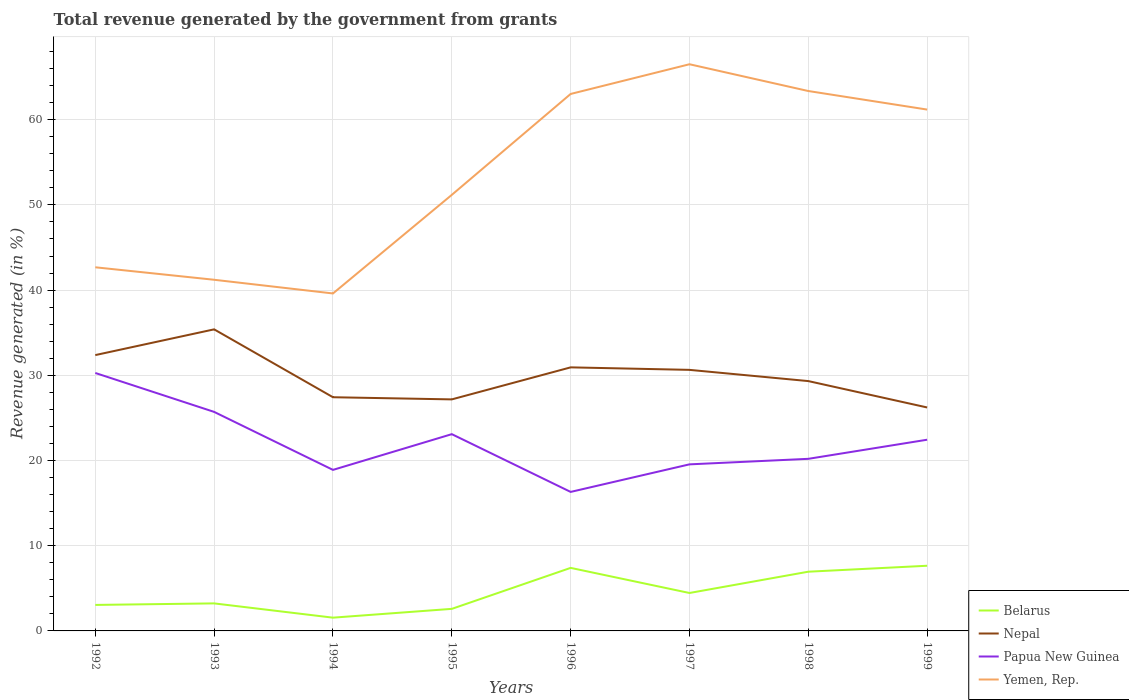Is the number of lines equal to the number of legend labels?
Your answer should be very brief. Yes. Across all years, what is the maximum total revenue generated in Belarus?
Offer a very short reply. 1.56. What is the total total revenue generated in Belarus in the graph?
Provide a short and direct response. -1.22. What is the difference between the highest and the second highest total revenue generated in Nepal?
Provide a succinct answer. 9.17. How many years are there in the graph?
Give a very brief answer. 8. Are the values on the major ticks of Y-axis written in scientific E-notation?
Your response must be concise. No. Does the graph contain grids?
Your answer should be very brief. Yes. How are the legend labels stacked?
Provide a succinct answer. Vertical. What is the title of the graph?
Provide a succinct answer. Total revenue generated by the government from grants. What is the label or title of the Y-axis?
Provide a succinct answer. Revenue generated (in %). What is the Revenue generated (in %) in Belarus in 1992?
Give a very brief answer. 3.05. What is the Revenue generated (in %) in Nepal in 1992?
Provide a short and direct response. 32.37. What is the Revenue generated (in %) in Papua New Guinea in 1992?
Offer a terse response. 30.27. What is the Revenue generated (in %) of Yemen, Rep. in 1992?
Provide a short and direct response. 42.68. What is the Revenue generated (in %) of Belarus in 1993?
Keep it short and to the point. 3.23. What is the Revenue generated (in %) of Nepal in 1993?
Give a very brief answer. 35.39. What is the Revenue generated (in %) in Papua New Guinea in 1993?
Your answer should be compact. 25.71. What is the Revenue generated (in %) of Yemen, Rep. in 1993?
Make the answer very short. 41.21. What is the Revenue generated (in %) of Belarus in 1994?
Provide a succinct answer. 1.56. What is the Revenue generated (in %) in Nepal in 1994?
Your answer should be compact. 27.43. What is the Revenue generated (in %) in Papua New Guinea in 1994?
Ensure brevity in your answer.  18.9. What is the Revenue generated (in %) of Yemen, Rep. in 1994?
Give a very brief answer. 39.61. What is the Revenue generated (in %) of Belarus in 1995?
Provide a succinct answer. 2.59. What is the Revenue generated (in %) in Nepal in 1995?
Provide a succinct answer. 27.18. What is the Revenue generated (in %) of Papua New Guinea in 1995?
Offer a terse response. 23.09. What is the Revenue generated (in %) in Yemen, Rep. in 1995?
Offer a terse response. 51.18. What is the Revenue generated (in %) in Belarus in 1996?
Ensure brevity in your answer.  7.4. What is the Revenue generated (in %) in Nepal in 1996?
Your response must be concise. 30.93. What is the Revenue generated (in %) of Papua New Guinea in 1996?
Your response must be concise. 16.32. What is the Revenue generated (in %) of Yemen, Rep. in 1996?
Your answer should be very brief. 63.02. What is the Revenue generated (in %) of Belarus in 1997?
Offer a terse response. 4.45. What is the Revenue generated (in %) of Nepal in 1997?
Offer a very short reply. 30.64. What is the Revenue generated (in %) in Papua New Guinea in 1997?
Offer a terse response. 19.55. What is the Revenue generated (in %) of Yemen, Rep. in 1997?
Offer a very short reply. 66.51. What is the Revenue generated (in %) in Belarus in 1998?
Give a very brief answer. 6.95. What is the Revenue generated (in %) in Nepal in 1998?
Provide a short and direct response. 29.32. What is the Revenue generated (in %) in Papua New Guinea in 1998?
Keep it short and to the point. 20.2. What is the Revenue generated (in %) of Yemen, Rep. in 1998?
Offer a very short reply. 63.37. What is the Revenue generated (in %) in Belarus in 1999?
Provide a short and direct response. 7.65. What is the Revenue generated (in %) in Nepal in 1999?
Give a very brief answer. 26.23. What is the Revenue generated (in %) of Papua New Guinea in 1999?
Keep it short and to the point. 22.44. What is the Revenue generated (in %) of Yemen, Rep. in 1999?
Make the answer very short. 61.19. Across all years, what is the maximum Revenue generated (in %) of Belarus?
Offer a very short reply. 7.65. Across all years, what is the maximum Revenue generated (in %) of Nepal?
Your answer should be very brief. 35.39. Across all years, what is the maximum Revenue generated (in %) of Papua New Guinea?
Your answer should be compact. 30.27. Across all years, what is the maximum Revenue generated (in %) in Yemen, Rep.?
Your answer should be compact. 66.51. Across all years, what is the minimum Revenue generated (in %) of Belarus?
Your answer should be very brief. 1.56. Across all years, what is the minimum Revenue generated (in %) in Nepal?
Ensure brevity in your answer.  26.23. Across all years, what is the minimum Revenue generated (in %) of Papua New Guinea?
Ensure brevity in your answer.  16.32. Across all years, what is the minimum Revenue generated (in %) in Yemen, Rep.?
Offer a terse response. 39.61. What is the total Revenue generated (in %) in Belarus in the graph?
Ensure brevity in your answer.  36.88. What is the total Revenue generated (in %) in Nepal in the graph?
Offer a terse response. 239.5. What is the total Revenue generated (in %) in Papua New Guinea in the graph?
Keep it short and to the point. 176.48. What is the total Revenue generated (in %) in Yemen, Rep. in the graph?
Offer a very short reply. 428.77. What is the difference between the Revenue generated (in %) of Belarus in 1992 and that in 1993?
Offer a very short reply. -0.18. What is the difference between the Revenue generated (in %) in Nepal in 1992 and that in 1993?
Give a very brief answer. -3.02. What is the difference between the Revenue generated (in %) of Papua New Guinea in 1992 and that in 1993?
Your answer should be very brief. 4.57. What is the difference between the Revenue generated (in %) in Yemen, Rep. in 1992 and that in 1993?
Your answer should be compact. 1.47. What is the difference between the Revenue generated (in %) of Belarus in 1992 and that in 1994?
Keep it short and to the point. 1.49. What is the difference between the Revenue generated (in %) of Nepal in 1992 and that in 1994?
Your answer should be compact. 4.95. What is the difference between the Revenue generated (in %) of Papua New Guinea in 1992 and that in 1994?
Provide a succinct answer. 11.37. What is the difference between the Revenue generated (in %) in Yemen, Rep. in 1992 and that in 1994?
Ensure brevity in your answer.  3.07. What is the difference between the Revenue generated (in %) of Belarus in 1992 and that in 1995?
Keep it short and to the point. 0.46. What is the difference between the Revenue generated (in %) of Nepal in 1992 and that in 1995?
Provide a short and direct response. 5.2. What is the difference between the Revenue generated (in %) of Papua New Guinea in 1992 and that in 1995?
Your response must be concise. 7.18. What is the difference between the Revenue generated (in %) in Yemen, Rep. in 1992 and that in 1995?
Ensure brevity in your answer.  -8.5. What is the difference between the Revenue generated (in %) in Belarus in 1992 and that in 1996?
Make the answer very short. -4.35. What is the difference between the Revenue generated (in %) in Nepal in 1992 and that in 1996?
Provide a succinct answer. 1.44. What is the difference between the Revenue generated (in %) in Papua New Guinea in 1992 and that in 1996?
Provide a succinct answer. 13.96. What is the difference between the Revenue generated (in %) of Yemen, Rep. in 1992 and that in 1996?
Your answer should be very brief. -20.34. What is the difference between the Revenue generated (in %) in Belarus in 1992 and that in 1997?
Offer a terse response. -1.4. What is the difference between the Revenue generated (in %) in Nepal in 1992 and that in 1997?
Make the answer very short. 1.74. What is the difference between the Revenue generated (in %) in Papua New Guinea in 1992 and that in 1997?
Your response must be concise. 10.73. What is the difference between the Revenue generated (in %) in Yemen, Rep. in 1992 and that in 1997?
Your response must be concise. -23.83. What is the difference between the Revenue generated (in %) of Belarus in 1992 and that in 1998?
Your answer should be compact. -3.9. What is the difference between the Revenue generated (in %) of Nepal in 1992 and that in 1998?
Your answer should be very brief. 3.05. What is the difference between the Revenue generated (in %) of Papua New Guinea in 1992 and that in 1998?
Provide a short and direct response. 10.08. What is the difference between the Revenue generated (in %) in Yemen, Rep. in 1992 and that in 1998?
Make the answer very short. -20.69. What is the difference between the Revenue generated (in %) in Belarus in 1992 and that in 1999?
Keep it short and to the point. -4.6. What is the difference between the Revenue generated (in %) in Nepal in 1992 and that in 1999?
Make the answer very short. 6.15. What is the difference between the Revenue generated (in %) of Papua New Guinea in 1992 and that in 1999?
Ensure brevity in your answer.  7.83. What is the difference between the Revenue generated (in %) in Yemen, Rep. in 1992 and that in 1999?
Your response must be concise. -18.51. What is the difference between the Revenue generated (in %) of Belarus in 1993 and that in 1994?
Ensure brevity in your answer.  1.67. What is the difference between the Revenue generated (in %) of Nepal in 1993 and that in 1994?
Provide a succinct answer. 7.97. What is the difference between the Revenue generated (in %) in Papua New Guinea in 1993 and that in 1994?
Your response must be concise. 6.81. What is the difference between the Revenue generated (in %) in Yemen, Rep. in 1993 and that in 1994?
Ensure brevity in your answer.  1.61. What is the difference between the Revenue generated (in %) of Belarus in 1993 and that in 1995?
Give a very brief answer. 0.64. What is the difference between the Revenue generated (in %) of Nepal in 1993 and that in 1995?
Your response must be concise. 8.22. What is the difference between the Revenue generated (in %) of Papua New Guinea in 1993 and that in 1995?
Provide a succinct answer. 2.61. What is the difference between the Revenue generated (in %) of Yemen, Rep. in 1993 and that in 1995?
Your response must be concise. -9.97. What is the difference between the Revenue generated (in %) of Belarus in 1993 and that in 1996?
Your response must be concise. -4.17. What is the difference between the Revenue generated (in %) in Nepal in 1993 and that in 1996?
Keep it short and to the point. 4.46. What is the difference between the Revenue generated (in %) in Papua New Guinea in 1993 and that in 1996?
Offer a very short reply. 9.39. What is the difference between the Revenue generated (in %) in Yemen, Rep. in 1993 and that in 1996?
Your answer should be compact. -21.81. What is the difference between the Revenue generated (in %) of Belarus in 1993 and that in 1997?
Give a very brief answer. -1.22. What is the difference between the Revenue generated (in %) of Nepal in 1993 and that in 1997?
Ensure brevity in your answer.  4.75. What is the difference between the Revenue generated (in %) in Papua New Guinea in 1993 and that in 1997?
Your response must be concise. 6.16. What is the difference between the Revenue generated (in %) of Yemen, Rep. in 1993 and that in 1997?
Your answer should be very brief. -25.3. What is the difference between the Revenue generated (in %) in Belarus in 1993 and that in 1998?
Your response must be concise. -3.72. What is the difference between the Revenue generated (in %) of Nepal in 1993 and that in 1998?
Offer a terse response. 6.07. What is the difference between the Revenue generated (in %) in Papua New Guinea in 1993 and that in 1998?
Keep it short and to the point. 5.51. What is the difference between the Revenue generated (in %) in Yemen, Rep. in 1993 and that in 1998?
Give a very brief answer. -22.15. What is the difference between the Revenue generated (in %) in Belarus in 1993 and that in 1999?
Provide a succinct answer. -4.42. What is the difference between the Revenue generated (in %) in Nepal in 1993 and that in 1999?
Your answer should be compact. 9.17. What is the difference between the Revenue generated (in %) in Papua New Guinea in 1993 and that in 1999?
Ensure brevity in your answer.  3.27. What is the difference between the Revenue generated (in %) of Yemen, Rep. in 1993 and that in 1999?
Offer a very short reply. -19.98. What is the difference between the Revenue generated (in %) in Belarus in 1994 and that in 1995?
Your answer should be very brief. -1.03. What is the difference between the Revenue generated (in %) in Nepal in 1994 and that in 1995?
Your answer should be very brief. 0.25. What is the difference between the Revenue generated (in %) in Papua New Guinea in 1994 and that in 1995?
Your response must be concise. -4.19. What is the difference between the Revenue generated (in %) of Yemen, Rep. in 1994 and that in 1995?
Ensure brevity in your answer.  -11.57. What is the difference between the Revenue generated (in %) of Belarus in 1994 and that in 1996?
Your answer should be very brief. -5.84. What is the difference between the Revenue generated (in %) of Nepal in 1994 and that in 1996?
Your answer should be very brief. -3.51. What is the difference between the Revenue generated (in %) of Papua New Guinea in 1994 and that in 1996?
Your answer should be compact. 2.59. What is the difference between the Revenue generated (in %) of Yemen, Rep. in 1994 and that in 1996?
Your response must be concise. -23.42. What is the difference between the Revenue generated (in %) of Belarus in 1994 and that in 1997?
Keep it short and to the point. -2.9. What is the difference between the Revenue generated (in %) in Nepal in 1994 and that in 1997?
Offer a very short reply. -3.21. What is the difference between the Revenue generated (in %) of Papua New Guinea in 1994 and that in 1997?
Offer a very short reply. -0.65. What is the difference between the Revenue generated (in %) in Yemen, Rep. in 1994 and that in 1997?
Provide a succinct answer. -26.9. What is the difference between the Revenue generated (in %) in Belarus in 1994 and that in 1998?
Your answer should be compact. -5.39. What is the difference between the Revenue generated (in %) of Nepal in 1994 and that in 1998?
Ensure brevity in your answer.  -1.89. What is the difference between the Revenue generated (in %) of Papua New Guinea in 1994 and that in 1998?
Make the answer very short. -1.3. What is the difference between the Revenue generated (in %) of Yemen, Rep. in 1994 and that in 1998?
Offer a terse response. -23.76. What is the difference between the Revenue generated (in %) in Belarus in 1994 and that in 1999?
Your answer should be very brief. -6.09. What is the difference between the Revenue generated (in %) of Nepal in 1994 and that in 1999?
Provide a succinct answer. 1.2. What is the difference between the Revenue generated (in %) of Papua New Guinea in 1994 and that in 1999?
Offer a very short reply. -3.54. What is the difference between the Revenue generated (in %) in Yemen, Rep. in 1994 and that in 1999?
Your answer should be very brief. -21.58. What is the difference between the Revenue generated (in %) of Belarus in 1995 and that in 1996?
Provide a short and direct response. -4.81. What is the difference between the Revenue generated (in %) of Nepal in 1995 and that in 1996?
Make the answer very short. -3.76. What is the difference between the Revenue generated (in %) of Papua New Guinea in 1995 and that in 1996?
Provide a succinct answer. 6.78. What is the difference between the Revenue generated (in %) of Yemen, Rep. in 1995 and that in 1996?
Your response must be concise. -11.84. What is the difference between the Revenue generated (in %) in Belarus in 1995 and that in 1997?
Your answer should be compact. -1.86. What is the difference between the Revenue generated (in %) in Nepal in 1995 and that in 1997?
Keep it short and to the point. -3.46. What is the difference between the Revenue generated (in %) of Papua New Guinea in 1995 and that in 1997?
Offer a terse response. 3.54. What is the difference between the Revenue generated (in %) in Yemen, Rep. in 1995 and that in 1997?
Keep it short and to the point. -15.33. What is the difference between the Revenue generated (in %) in Belarus in 1995 and that in 1998?
Provide a succinct answer. -4.36. What is the difference between the Revenue generated (in %) in Nepal in 1995 and that in 1998?
Provide a short and direct response. -2.15. What is the difference between the Revenue generated (in %) of Papua New Guinea in 1995 and that in 1998?
Provide a short and direct response. 2.9. What is the difference between the Revenue generated (in %) in Yemen, Rep. in 1995 and that in 1998?
Make the answer very short. -12.19. What is the difference between the Revenue generated (in %) of Belarus in 1995 and that in 1999?
Provide a succinct answer. -5.06. What is the difference between the Revenue generated (in %) of Nepal in 1995 and that in 1999?
Give a very brief answer. 0.95. What is the difference between the Revenue generated (in %) of Papua New Guinea in 1995 and that in 1999?
Make the answer very short. 0.65. What is the difference between the Revenue generated (in %) of Yemen, Rep. in 1995 and that in 1999?
Make the answer very short. -10.01. What is the difference between the Revenue generated (in %) in Belarus in 1996 and that in 1997?
Make the answer very short. 2.95. What is the difference between the Revenue generated (in %) in Nepal in 1996 and that in 1997?
Offer a terse response. 0.29. What is the difference between the Revenue generated (in %) of Papua New Guinea in 1996 and that in 1997?
Your response must be concise. -3.23. What is the difference between the Revenue generated (in %) in Yemen, Rep. in 1996 and that in 1997?
Keep it short and to the point. -3.49. What is the difference between the Revenue generated (in %) of Belarus in 1996 and that in 1998?
Offer a very short reply. 0.45. What is the difference between the Revenue generated (in %) of Nepal in 1996 and that in 1998?
Offer a very short reply. 1.61. What is the difference between the Revenue generated (in %) in Papua New Guinea in 1996 and that in 1998?
Provide a succinct answer. -3.88. What is the difference between the Revenue generated (in %) in Yemen, Rep. in 1996 and that in 1998?
Ensure brevity in your answer.  -0.35. What is the difference between the Revenue generated (in %) in Belarus in 1996 and that in 1999?
Offer a terse response. -0.25. What is the difference between the Revenue generated (in %) in Nepal in 1996 and that in 1999?
Provide a short and direct response. 4.71. What is the difference between the Revenue generated (in %) of Papua New Guinea in 1996 and that in 1999?
Make the answer very short. -6.13. What is the difference between the Revenue generated (in %) in Yemen, Rep. in 1996 and that in 1999?
Keep it short and to the point. 1.83. What is the difference between the Revenue generated (in %) in Belarus in 1997 and that in 1998?
Your answer should be very brief. -2.5. What is the difference between the Revenue generated (in %) in Nepal in 1997 and that in 1998?
Your answer should be very brief. 1.32. What is the difference between the Revenue generated (in %) of Papua New Guinea in 1997 and that in 1998?
Your response must be concise. -0.65. What is the difference between the Revenue generated (in %) in Yemen, Rep. in 1997 and that in 1998?
Your answer should be compact. 3.14. What is the difference between the Revenue generated (in %) of Belarus in 1997 and that in 1999?
Your answer should be compact. -3.2. What is the difference between the Revenue generated (in %) in Nepal in 1997 and that in 1999?
Keep it short and to the point. 4.41. What is the difference between the Revenue generated (in %) in Papua New Guinea in 1997 and that in 1999?
Make the answer very short. -2.89. What is the difference between the Revenue generated (in %) of Yemen, Rep. in 1997 and that in 1999?
Make the answer very short. 5.32. What is the difference between the Revenue generated (in %) of Belarus in 1998 and that in 1999?
Keep it short and to the point. -0.7. What is the difference between the Revenue generated (in %) in Nepal in 1998 and that in 1999?
Give a very brief answer. 3.09. What is the difference between the Revenue generated (in %) in Papua New Guinea in 1998 and that in 1999?
Your answer should be very brief. -2.24. What is the difference between the Revenue generated (in %) in Yemen, Rep. in 1998 and that in 1999?
Your answer should be very brief. 2.18. What is the difference between the Revenue generated (in %) in Belarus in 1992 and the Revenue generated (in %) in Nepal in 1993?
Give a very brief answer. -32.34. What is the difference between the Revenue generated (in %) of Belarus in 1992 and the Revenue generated (in %) of Papua New Guinea in 1993?
Make the answer very short. -22.66. What is the difference between the Revenue generated (in %) in Belarus in 1992 and the Revenue generated (in %) in Yemen, Rep. in 1993?
Offer a terse response. -38.16. What is the difference between the Revenue generated (in %) in Nepal in 1992 and the Revenue generated (in %) in Papua New Guinea in 1993?
Offer a terse response. 6.67. What is the difference between the Revenue generated (in %) in Nepal in 1992 and the Revenue generated (in %) in Yemen, Rep. in 1993?
Your answer should be compact. -8.84. What is the difference between the Revenue generated (in %) of Papua New Guinea in 1992 and the Revenue generated (in %) of Yemen, Rep. in 1993?
Give a very brief answer. -10.94. What is the difference between the Revenue generated (in %) of Belarus in 1992 and the Revenue generated (in %) of Nepal in 1994?
Ensure brevity in your answer.  -24.38. What is the difference between the Revenue generated (in %) in Belarus in 1992 and the Revenue generated (in %) in Papua New Guinea in 1994?
Your response must be concise. -15.85. What is the difference between the Revenue generated (in %) in Belarus in 1992 and the Revenue generated (in %) in Yemen, Rep. in 1994?
Offer a very short reply. -36.56. What is the difference between the Revenue generated (in %) in Nepal in 1992 and the Revenue generated (in %) in Papua New Guinea in 1994?
Your response must be concise. 13.47. What is the difference between the Revenue generated (in %) in Nepal in 1992 and the Revenue generated (in %) in Yemen, Rep. in 1994?
Offer a terse response. -7.23. What is the difference between the Revenue generated (in %) in Papua New Guinea in 1992 and the Revenue generated (in %) in Yemen, Rep. in 1994?
Offer a terse response. -9.33. What is the difference between the Revenue generated (in %) of Belarus in 1992 and the Revenue generated (in %) of Nepal in 1995?
Keep it short and to the point. -24.12. What is the difference between the Revenue generated (in %) in Belarus in 1992 and the Revenue generated (in %) in Papua New Guinea in 1995?
Provide a succinct answer. -20.04. What is the difference between the Revenue generated (in %) in Belarus in 1992 and the Revenue generated (in %) in Yemen, Rep. in 1995?
Keep it short and to the point. -48.13. What is the difference between the Revenue generated (in %) in Nepal in 1992 and the Revenue generated (in %) in Papua New Guinea in 1995?
Provide a short and direct response. 9.28. What is the difference between the Revenue generated (in %) of Nepal in 1992 and the Revenue generated (in %) of Yemen, Rep. in 1995?
Provide a short and direct response. -18.81. What is the difference between the Revenue generated (in %) of Papua New Guinea in 1992 and the Revenue generated (in %) of Yemen, Rep. in 1995?
Your response must be concise. -20.91. What is the difference between the Revenue generated (in %) in Belarus in 1992 and the Revenue generated (in %) in Nepal in 1996?
Keep it short and to the point. -27.88. What is the difference between the Revenue generated (in %) of Belarus in 1992 and the Revenue generated (in %) of Papua New Guinea in 1996?
Offer a very short reply. -13.26. What is the difference between the Revenue generated (in %) of Belarus in 1992 and the Revenue generated (in %) of Yemen, Rep. in 1996?
Keep it short and to the point. -59.97. What is the difference between the Revenue generated (in %) in Nepal in 1992 and the Revenue generated (in %) in Papua New Guinea in 1996?
Your response must be concise. 16.06. What is the difference between the Revenue generated (in %) of Nepal in 1992 and the Revenue generated (in %) of Yemen, Rep. in 1996?
Your answer should be very brief. -30.65. What is the difference between the Revenue generated (in %) of Papua New Guinea in 1992 and the Revenue generated (in %) of Yemen, Rep. in 1996?
Keep it short and to the point. -32.75. What is the difference between the Revenue generated (in %) of Belarus in 1992 and the Revenue generated (in %) of Nepal in 1997?
Ensure brevity in your answer.  -27.59. What is the difference between the Revenue generated (in %) of Belarus in 1992 and the Revenue generated (in %) of Papua New Guinea in 1997?
Your response must be concise. -16.5. What is the difference between the Revenue generated (in %) in Belarus in 1992 and the Revenue generated (in %) in Yemen, Rep. in 1997?
Your answer should be compact. -63.46. What is the difference between the Revenue generated (in %) of Nepal in 1992 and the Revenue generated (in %) of Papua New Guinea in 1997?
Offer a very short reply. 12.83. What is the difference between the Revenue generated (in %) of Nepal in 1992 and the Revenue generated (in %) of Yemen, Rep. in 1997?
Keep it short and to the point. -34.13. What is the difference between the Revenue generated (in %) of Papua New Guinea in 1992 and the Revenue generated (in %) of Yemen, Rep. in 1997?
Offer a very short reply. -36.23. What is the difference between the Revenue generated (in %) of Belarus in 1992 and the Revenue generated (in %) of Nepal in 1998?
Give a very brief answer. -26.27. What is the difference between the Revenue generated (in %) of Belarus in 1992 and the Revenue generated (in %) of Papua New Guinea in 1998?
Your response must be concise. -17.15. What is the difference between the Revenue generated (in %) in Belarus in 1992 and the Revenue generated (in %) in Yemen, Rep. in 1998?
Provide a succinct answer. -60.32. What is the difference between the Revenue generated (in %) in Nepal in 1992 and the Revenue generated (in %) in Papua New Guinea in 1998?
Your answer should be compact. 12.18. What is the difference between the Revenue generated (in %) of Nepal in 1992 and the Revenue generated (in %) of Yemen, Rep. in 1998?
Your answer should be very brief. -30.99. What is the difference between the Revenue generated (in %) in Papua New Guinea in 1992 and the Revenue generated (in %) in Yemen, Rep. in 1998?
Make the answer very short. -33.09. What is the difference between the Revenue generated (in %) in Belarus in 1992 and the Revenue generated (in %) in Nepal in 1999?
Keep it short and to the point. -23.18. What is the difference between the Revenue generated (in %) in Belarus in 1992 and the Revenue generated (in %) in Papua New Guinea in 1999?
Your answer should be compact. -19.39. What is the difference between the Revenue generated (in %) of Belarus in 1992 and the Revenue generated (in %) of Yemen, Rep. in 1999?
Your answer should be compact. -58.14. What is the difference between the Revenue generated (in %) of Nepal in 1992 and the Revenue generated (in %) of Papua New Guinea in 1999?
Your response must be concise. 9.93. What is the difference between the Revenue generated (in %) in Nepal in 1992 and the Revenue generated (in %) in Yemen, Rep. in 1999?
Offer a terse response. -28.82. What is the difference between the Revenue generated (in %) in Papua New Guinea in 1992 and the Revenue generated (in %) in Yemen, Rep. in 1999?
Keep it short and to the point. -30.92. What is the difference between the Revenue generated (in %) of Belarus in 1993 and the Revenue generated (in %) of Nepal in 1994?
Offer a very short reply. -24.2. What is the difference between the Revenue generated (in %) in Belarus in 1993 and the Revenue generated (in %) in Papua New Guinea in 1994?
Your answer should be very brief. -15.67. What is the difference between the Revenue generated (in %) in Belarus in 1993 and the Revenue generated (in %) in Yemen, Rep. in 1994?
Your response must be concise. -36.38. What is the difference between the Revenue generated (in %) in Nepal in 1993 and the Revenue generated (in %) in Papua New Guinea in 1994?
Ensure brevity in your answer.  16.49. What is the difference between the Revenue generated (in %) of Nepal in 1993 and the Revenue generated (in %) of Yemen, Rep. in 1994?
Give a very brief answer. -4.21. What is the difference between the Revenue generated (in %) in Belarus in 1993 and the Revenue generated (in %) in Nepal in 1995?
Your answer should be very brief. -23.94. What is the difference between the Revenue generated (in %) in Belarus in 1993 and the Revenue generated (in %) in Papua New Guinea in 1995?
Provide a succinct answer. -19.86. What is the difference between the Revenue generated (in %) of Belarus in 1993 and the Revenue generated (in %) of Yemen, Rep. in 1995?
Offer a terse response. -47.95. What is the difference between the Revenue generated (in %) of Nepal in 1993 and the Revenue generated (in %) of Papua New Guinea in 1995?
Provide a succinct answer. 12.3. What is the difference between the Revenue generated (in %) of Nepal in 1993 and the Revenue generated (in %) of Yemen, Rep. in 1995?
Your answer should be compact. -15.79. What is the difference between the Revenue generated (in %) in Papua New Guinea in 1993 and the Revenue generated (in %) in Yemen, Rep. in 1995?
Provide a short and direct response. -25.47. What is the difference between the Revenue generated (in %) in Belarus in 1993 and the Revenue generated (in %) in Nepal in 1996?
Make the answer very short. -27.7. What is the difference between the Revenue generated (in %) in Belarus in 1993 and the Revenue generated (in %) in Papua New Guinea in 1996?
Your response must be concise. -13.08. What is the difference between the Revenue generated (in %) in Belarus in 1993 and the Revenue generated (in %) in Yemen, Rep. in 1996?
Offer a very short reply. -59.79. What is the difference between the Revenue generated (in %) in Nepal in 1993 and the Revenue generated (in %) in Papua New Guinea in 1996?
Provide a succinct answer. 19.08. What is the difference between the Revenue generated (in %) of Nepal in 1993 and the Revenue generated (in %) of Yemen, Rep. in 1996?
Ensure brevity in your answer.  -27.63. What is the difference between the Revenue generated (in %) of Papua New Guinea in 1993 and the Revenue generated (in %) of Yemen, Rep. in 1996?
Make the answer very short. -37.32. What is the difference between the Revenue generated (in %) of Belarus in 1993 and the Revenue generated (in %) of Nepal in 1997?
Your answer should be very brief. -27.41. What is the difference between the Revenue generated (in %) in Belarus in 1993 and the Revenue generated (in %) in Papua New Guinea in 1997?
Provide a short and direct response. -16.32. What is the difference between the Revenue generated (in %) of Belarus in 1993 and the Revenue generated (in %) of Yemen, Rep. in 1997?
Provide a succinct answer. -63.28. What is the difference between the Revenue generated (in %) in Nepal in 1993 and the Revenue generated (in %) in Papua New Guinea in 1997?
Offer a very short reply. 15.84. What is the difference between the Revenue generated (in %) in Nepal in 1993 and the Revenue generated (in %) in Yemen, Rep. in 1997?
Offer a terse response. -31.12. What is the difference between the Revenue generated (in %) of Papua New Guinea in 1993 and the Revenue generated (in %) of Yemen, Rep. in 1997?
Make the answer very short. -40.8. What is the difference between the Revenue generated (in %) in Belarus in 1993 and the Revenue generated (in %) in Nepal in 1998?
Your answer should be compact. -26.09. What is the difference between the Revenue generated (in %) in Belarus in 1993 and the Revenue generated (in %) in Papua New Guinea in 1998?
Offer a terse response. -16.97. What is the difference between the Revenue generated (in %) in Belarus in 1993 and the Revenue generated (in %) in Yemen, Rep. in 1998?
Keep it short and to the point. -60.14. What is the difference between the Revenue generated (in %) of Nepal in 1993 and the Revenue generated (in %) of Papua New Guinea in 1998?
Provide a short and direct response. 15.2. What is the difference between the Revenue generated (in %) in Nepal in 1993 and the Revenue generated (in %) in Yemen, Rep. in 1998?
Your answer should be compact. -27.97. What is the difference between the Revenue generated (in %) of Papua New Guinea in 1993 and the Revenue generated (in %) of Yemen, Rep. in 1998?
Your answer should be very brief. -37.66. What is the difference between the Revenue generated (in %) in Belarus in 1993 and the Revenue generated (in %) in Nepal in 1999?
Offer a very short reply. -23. What is the difference between the Revenue generated (in %) in Belarus in 1993 and the Revenue generated (in %) in Papua New Guinea in 1999?
Offer a very short reply. -19.21. What is the difference between the Revenue generated (in %) in Belarus in 1993 and the Revenue generated (in %) in Yemen, Rep. in 1999?
Give a very brief answer. -57.96. What is the difference between the Revenue generated (in %) in Nepal in 1993 and the Revenue generated (in %) in Papua New Guinea in 1999?
Make the answer very short. 12.95. What is the difference between the Revenue generated (in %) in Nepal in 1993 and the Revenue generated (in %) in Yemen, Rep. in 1999?
Ensure brevity in your answer.  -25.8. What is the difference between the Revenue generated (in %) of Papua New Guinea in 1993 and the Revenue generated (in %) of Yemen, Rep. in 1999?
Give a very brief answer. -35.48. What is the difference between the Revenue generated (in %) in Belarus in 1994 and the Revenue generated (in %) in Nepal in 1995?
Offer a very short reply. -25.62. What is the difference between the Revenue generated (in %) in Belarus in 1994 and the Revenue generated (in %) in Papua New Guinea in 1995?
Keep it short and to the point. -21.54. What is the difference between the Revenue generated (in %) in Belarus in 1994 and the Revenue generated (in %) in Yemen, Rep. in 1995?
Your answer should be very brief. -49.62. What is the difference between the Revenue generated (in %) in Nepal in 1994 and the Revenue generated (in %) in Papua New Guinea in 1995?
Provide a short and direct response. 4.33. What is the difference between the Revenue generated (in %) of Nepal in 1994 and the Revenue generated (in %) of Yemen, Rep. in 1995?
Provide a succinct answer. -23.75. What is the difference between the Revenue generated (in %) of Papua New Guinea in 1994 and the Revenue generated (in %) of Yemen, Rep. in 1995?
Your response must be concise. -32.28. What is the difference between the Revenue generated (in %) in Belarus in 1994 and the Revenue generated (in %) in Nepal in 1996?
Your response must be concise. -29.38. What is the difference between the Revenue generated (in %) in Belarus in 1994 and the Revenue generated (in %) in Papua New Guinea in 1996?
Your answer should be very brief. -14.76. What is the difference between the Revenue generated (in %) of Belarus in 1994 and the Revenue generated (in %) of Yemen, Rep. in 1996?
Your response must be concise. -61.47. What is the difference between the Revenue generated (in %) of Nepal in 1994 and the Revenue generated (in %) of Papua New Guinea in 1996?
Keep it short and to the point. 11.11. What is the difference between the Revenue generated (in %) of Nepal in 1994 and the Revenue generated (in %) of Yemen, Rep. in 1996?
Offer a terse response. -35.59. What is the difference between the Revenue generated (in %) of Papua New Guinea in 1994 and the Revenue generated (in %) of Yemen, Rep. in 1996?
Provide a succinct answer. -44.12. What is the difference between the Revenue generated (in %) in Belarus in 1994 and the Revenue generated (in %) in Nepal in 1997?
Your answer should be very brief. -29.08. What is the difference between the Revenue generated (in %) of Belarus in 1994 and the Revenue generated (in %) of Papua New Guinea in 1997?
Provide a succinct answer. -17.99. What is the difference between the Revenue generated (in %) of Belarus in 1994 and the Revenue generated (in %) of Yemen, Rep. in 1997?
Offer a very short reply. -64.95. What is the difference between the Revenue generated (in %) of Nepal in 1994 and the Revenue generated (in %) of Papua New Guinea in 1997?
Your response must be concise. 7.88. What is the difference between the Revenue generated (in %) in Nepal in 1994 and the Revenue generated (in %) in Yemen, Rep. in 1997?
Ensure brevity in your answer.  -39.08. What is the difference between the Revenue generated (in %) in Papua New Guinea in 1994 and the Revenue generated (in %) in Yemen, Rep. in 1997?
Offer a very short reply. -47.61. What is the difference between the Revenue generated (in %) of Belarus in 1994 and the Revenue generated (in %) of Nepal in 1998?
Your response must be concise. -27.77. What is the difference between the Revenue generated (in %) of Belarus in 1994 and the Revenue generated (in %) of Papua New Guinea in 1998?
Keep it short and to the point. -18.64. What is the difference between the Revenue generated (in %) of Belarus in 1994 and the Revenue generated (in %) of Yemen, Rep. in 1998?
Offer a terse response. -61.81. What is the difference between the Revenue generated (in %) in Nepal in 1994 and the Revenue generated (in %) in Papua New Guinea in 1998?
Your response must be concise. 7.23. What is the difference between the Revenue generated (in %) in Nepal in 1994 and the Revenue generated (in %) in Yemen, Rep. in 1998?
Provide a succinct answer. -35.94. What is the difference between the Revenue generated (in %) of Papua New Guinea in 1994 and the Revenue generated (in %) of Yemen, Rep. in 1998?
Keep it short and to the point. -44.47. What is the difference between the Revenue generated (in %) of Belarus in 1994 and the Revenue generated (in %) of Nepal in 1999?
Ensure brevity in your answer.  -24.67. What is the difference between the Revenue generated (in %) of Belarus in 1994 and the Revenue generated (in %) of Papua New Guinea in 1999?
Give a very brief answer. -20.88. What is the difference between the Revenue generated (in %) in Belarus in 1994 and the Revenue generated (in %) in Yemen, Rep. in 1999?
Your response must be concise. -59.63. What is the difference between the Revenue generated (in %) in Nepal in 1994 and the Revenue generated (in %) in Papua New Guinea in 1999?
Provide a succinct answer. 4.99. What is the difference between the Revenue generated (in %) of Nepal in 1994 and the Revenue generated (in %) of Yemen, Rep. in 1999?
Your response must be concise. -33.76. What is the difference between the Revenue generated (in %) of Papua New Guinea in 1994 and the Revenue generated (in %) of Yemen, Rep. in 1999?
Offer a very short reply. -42.29. What is the difference between the Revenue generated (in %) of Belarus in 1995 and the Revenue generated (in %) of Nepal in 1996?
Offer a very short reply. -28.34. What is the difference between the Revenue generated (in %) of Belarus in 1995 and the Revenue generated (in %) of Papua New Guinea in 1996?
Give a very brief answer. -13.73. What is the difference between the Revenue generated (in %) in Belarus in 1995 and the Revenue generated (in %) in Yemen, Rep. in 1996?
Offer a terse response. -60.43. What is the difference between the Revenue generated (in %) in Nepal in 1995 and the Revenue generated (in %) in Papua New Guinea in 1996?
Provide a succinct answer. 10.86. What is the difference between the Revenue generated (in %) of Nepal in 1995 and the Revenue generated (in %) of Yemen, Rep. in 1996?
Ensure brevity in your answer.  -35.85. What is the difference between the Revenue generated (in %) in Papua New Guinea in 1995 and the Revenue generated (in %) in Yemen, Rep. in 1996?
Make the answer very short. -39.93. What is the difference between the Revenue generated (in %) of Belarus in 1995 and the Revenue generated (in %) of Nepal in 1997?
Make the answer very short. -28.05. What is the difference between the Revenue generated (in %) of Belarus in 1995 and the Revenue generated (in %) of Papua New Guinea in 1997?
Make the answer very short. -16.96. What is the difference between the Revenue generated (in %) in Belarus in 1995 and the Revenue generated (in %) in Yemen, Rep. in 1997?
Your response must be concise. -63.92. What is the difference between the Revenue generated (in %) of Nepal in 1995 and the Revenue generated (in %) of Papua New Guinea in 1997?
Offer a terse response. 7.63. What is the difference between the Revenue generated (in %) of Nepal in 1995 and the Revenue generated (in %) of Yemen, Rep. in 1997?
Give a very brief answer. -39.33. What is the difference between the Revenue generated (in %) in Papua New Guinea in 1995 and the Revenue generated (in %) in Yemen, Rep. in 1997?
Provide a succinct answer. -43.42. What is the difference between the Revenue generated (in %) of Belarus in 1995 and the Revenue generated (in %) of Nepal in 1998?
Provide a short and direct response. -26.73. What is the difference between the Revenue generated (in %) of Belarus in 1995 and the Revenue generated (in %) of Papua New Guinea in 1998?
Ensure brevity in your answer.  -17.61. What is the difference between the Revenue generated (in %) in Belarus in 1995 and the Revenue generated (in %) in Yemen, Rep. in 1998?
Keep it short and to the point. -60.78. What is the difference between the Revenue generated (in %) in Nepal in 1995 and the Revenue generated (in %) in Papua New Guinea in 1998?
Keep it short and to the point. 6.98. What is the difference between the Revenue generated (in %) in Nepal in 1995 and the Revenue generated (in %) in Yemen, Rep. in 1998?
Keep it short and to the point. -36.19. What is the difference between the Revenue generated (in %) in Papua New Guinea in 1995 and the Revenue generated (in %) in Yemen, Rep. in 1998?
Your response must be concise. -40.27. What is the difference between the Revenue generated (in %) in Belarus in 1995 and the Revenue generated (in %) in Nepal in 1999?
Your answer should be very brief. -23.64. What is the difference between the Revenue generated (in %) in Belarus in 1995 and the Revenue generated (in %) in Papua New Guinea in 1999?
Offer a terse response. -19.85. What is the difference between the Revenue generated (in %) of Belarus in 1995 and the Revenue generated (in %) of Yemen, Rep. in 1999?
Your answer should be compact. -58.6. What is the difference between the Revenue generated (in %) in Nepal in 1995 and the Revenue generated (in %) in Papua New Guinea in 1999?
Ensure brevity in your answer.  4.73. What is the difference between the Revenue generated (in %) in Nepal in 1995 and the Revenue generated (in %) in Yemen, Rep. in 1999?
Provide a short and direct response. -34.01. What is the difference between the Revenue generated (in %) in Papua New Guinea in 1995 and the Revenue generated (in %) in Yemen, Rep. in 1999?
Your answer should be compact. -38.1. What is the difference between the Revenue generated (in %) of Belarus in 1996 and the Revenue generated (in %) of Nepal in 1997?
Offer a very short reply. -23.24. What is the difference between the Revenue generated (in %) in Belarus in 1996 and the Revenue generated (in %) in Papua New Guinea in 1997?
Provide a succinct answer. -12.15. What is the difference between the Revenue generated (in %) of Belarus in 1996 and the Revenue generated (in %) of Yemen, Rep. in 1997?
Your response must be concise. -59.11. What is the difference between the Revenue generated (in %) in Nepal in 1996 and the Revenue generated (in %) in Papua New Guinea in 1997?
Provide a succinct answer. 11.38. What is the difference between the Revenue generated (in %) in Nepal in 1996 and the Revenue generated (in %) in Yemen, Rep. in 1997?
Give a very brief answer. -35.58. What is the difference between the Revenue generated (in %) in Papua New Guinea in 1996 and the Revenue generated (in %) in Yemen, Rep. in 1997?
Give a very brief answer. -50.19. What is the difference between the Revenue generated (in %) in Belarus in 1996 and the Revenue generated (in %) in Nepal in 1998?
Ensure brevity in your answer.  -21.92. What is the difference between the Revenue generated (in %) of Belarus in 1996 and the Revenue generated (in %) of Papua New Guinea in 1998?
Your answer should be very brief. -12.8. What is the difference between the Revenue generated (in %) of Belarus in 1996 and the Revenue generated (in %) of Yemen, Rep. in 1998?
Offer a terse response. -55.97. What is the difference between the Revenue generated (in %) of Nepal in 1996 and the Revenue generated (in %) of Papua New Guinea in 1998?
Provide a succinct answer. 10.74. What is the difference between the Revenue generated (in %) in Nepal in 1996 and the Revenue generated (in %) in Yemen, Rep. in 1998?
Your response must be concise. -32.43. What is the difference between the Revenue generated (in %) in Papua New Guinea in 1996 and the Revenue generated (in %) in Yemen, Rep. in 1998?
Provide a succinct answer. -47.05. What is the difference between the Revenue generated (in %) of Belarus in 1996 and the Revenue generated (in %) of Nepal in 1999?
Make the answer very short. -18.83. What is the difference between the Revenue generated (in %) in Belarus in 1996 and the Revenue generated (in %) in Papua New Guinea in 1999?
Offer a terse response. -15.04. What is the difference between the Revenue generated (in %) of Belarus in 1996 and the Revenue generated (in %) of Yemen, Rep. in 1999?
Your response must be concise. -53.79. What is the difference between the Revenue generated (in %) in Nepal in 1996 and the Revenue generated (in %) in Papua New Guinea in 1999?
Offer a terse response. 8.49. What is the difference between the Revenue generated (in %) of Nepal in 1996 and the Revenue generated (in %) of Yemen, Rep. in 1999?
Offer a very short reply. -30.26. What is the difference between the Revenue generated (in %) of Papua New Guinea in 1996 and the Revenue generated (in %) of Yemen, Rep. in 1999?
Keep it short and to the point. -44.87. What is the difference between the Revenue generated (in %) of Belarus in 1997 and the Revenue generated (in %) of Nepal in 1998?
Keep it short and to the point. -24.87. What is the difference between the Revenue generated (in %) in Belarus in 1997 and the Revenue generated (in %) in Papua New Guinea in 1998?
Give a very brief answer. -15.75. What is the difference between the Revenue generated (in %) of Belarus in 1997 and the Revenue generated (in %) of Yemen, Rep. in 1998?
Make the answer very short. -58.92. What is the difference between the Revenue generated (in %) in Nepal in 1997 and the Revenue generated (in %) in Papua New Guinea in 1998?
Make the answer very short. 10.44. What is the difference between the Revenue generated (in %) of Nepal in 1997 and the Revenue generated (in %) of Yemen, Rep. in 1998?
Give a very brief answer. -32.73. What is the difference between the Revenue generated (in %) in Papua New Guinea in 1997 and the Revenue generated (in %) in Yemen, Rep. in 1998?
Your answer should be very brief. -43.82. What is the difference between the Revenue generated (in %) in Belarus in 1997 and the Revenue generated (in %) in Nepal in 1999?
Ensure brevity in your answer.  -21.78. What is the difference between the Revenue generated (in %) of Belarus in 1997 and the Revenue generated (in %) of Papua New Guinea in 1999?
Keep it short and to the point. -17.99. What is the difference between the Revenue generated (in %) in Belarus in 1997 and the Revenue generated (in %) in Yemen, Rep. in 1999?
Your answer should be very brief. -56.74. What is the difference between the Revenue generated (in %) in Nepal in 1997 and the Revenue generated (in %) in Papua New Guinea in 1999?
Make the answer very short. 8.2. What is the difference between the Revenue generated (in %) in Nepal in 1997 and the Revenue generated (in %) in Yemen, Rep. in 1999?
Offer a terse response. -30.55. What is the difference between the Revenue generated (in %) in Papua New Guinea in 1997 and the Revenue generated (in %) in Yemen, Rep. in 1999?
Your answer should be compact. -41.64. What is the difference between the Revenue generated (in %) in Belarus in 1998 and the Revenue generated (in %) in Nepal in 1999?
Your response must be concise. -19.28. What is the difference between the Revenue generated (in %) of Belarus in 1998 and the Revenue generated (in %) of Papua New Guinea in 1999?
Your answer should be compact. -15.49. What is the difference between the Revenue generated (in %) in Belarus in 1998 and the Revenue generated (in %) in Yemen, Rep. in 1999?
Keep it short and to the point. -54.24. What is the difference between the Revenue generated (in %) in Nepal in 1998 and the Revenue generated (in %) in Papua New Guinea in 1999?
Offer a very short reply. 6.88. What is the difference between the Revenue generated (in %) in Nepal in 1998 and the Revenue generated (in %) in Yemen, Rep. in 1999?
Your answer should be very brief. -31.87. What is the difference between the Revenue generated (in %) in Papua New Guinea in 1998 and the Revenue generated (in %) in Yemen, Rep. in 1999?
Offer a very short reply. -40.99. What is the average Revenue generated (in %) of Belarus per year?
Provide a short and direct response. 4.61. What is the average Revenue generated (in %) of Nepal per year?
Provide a succinct answer. 29.94. What is the average Revenue generated (in %) of Papua New Guinea per year?
Give a very brief answer. 22.06. What is the average Revenue generated (in %) of Yemen, Rep. per year?
Give a very brief answer. 53.6. In the year 1992, what is the difference between the Revenue generated (in %) of Belarus and Revenue generated (in %) of Nepal?
Keep it short and to the point. -29.32. In the year 1992, what is the difference between the Revenue generated (in %) of Belarus and Revenue generated (in %) of Papua New Guinea?
Your answer should be very brief. -27.22. In the year 1992, what is the difference between the Revenue generated (in %) in Belarus and Revenue generated (in %) in Yemen, Rep.?
Your response must be concise. -39.63. In the year 1992, what is the difference between the Revenue generated (in %) of Nepal and Revenue generated (in %) of Papua New Guinea?
Offer a terse response. 2.1. In the year 1992, what is the difference between the Revenue generated (in %) of Nepal and Revenue generated (in %) of Yemen, Rep.?
Ensure brevity in your answer.  -10.3. In the year 1992, what is the difference between the Revenue generated (in %) of Papua New Guinea and Revenue generated (in %) of Yemen, Rep.?
Provide a succinct answer. -12.4. In the year 1993, what is the difference between the Revenue generated (in %) of Belarus and Revenue generated (in %) of Nepal?
Keep it short and to the point. -32.16. In the year 1993, what is the difference between the Revenue generated (in %) in Belarus and Revenue generated (in %) in Papua New Guinea?
Your answer should be very brief. -22.48. In the year 1993, what is the difference between the Revenue generated (in %) in Belarus and Revenue generated (in %) in Yemen, Rep.?
Offer a very short reply. -37.98. In the year 1993, what is the difference between the Revenue generated (in %) of Nepal and Revenue generated (in %) of Papua New Guinea?
Keep it short and to the point. 9.69. In the year 1993, what is the difference between the Revenue generated (in %) of Nepal and Revenue generated (in %) of Yemen, Rep.?
Offer a terse response. -5.82. In the year 1993, what is the difference between the Revenue generated (in %) in Papua New Guinea and Revenue generated (in %) in Yemen, Rep.?
Your response must be concise. -15.51. In the year 1994, what is the difference between the Revenue generated (in %) of Belarus and Revenue generated (in %) of Nepal?
Ensure brevity in your answer.  -25.87. In the year 1994, what is the difference between the Revenue generated (in %) in Belarus and Revenue generated (in %) in Papua New Guinea?
Offer a terse response. -17.34. In the year 1994, what is the difference between the Revenue generated (in %) in Belarus and Revenue generated (in %) in Yemen, Rep.?
Your answer should be very brief. -38.05. In the year 1994, what is the difference between the Revenue generated (in %) in Nepal and Revenue generated (in %) in Papua New Guinea?
Keep it short and to the point. 8.53. In the year 1994, what is the difference between the Revenue generated (in %) in Nepal and Revenue generated (in %) in Yemen, Rep.?
Offer a terse response. -12.18. In the year 1994, what is the difference between the Revenue generated (in %) of Papua New Guinea and Revenue generated (in %) of Yemen, Rep.?
Provide a succinct answer. -20.71. In the year 1995, what is the difference between the Revenue generated (in %) of Belarus and Revenue generated (in %) of Nepal?
Provide a succinct answer. -24.59. In the year 1995, what is the difference between the Revenue generated (in %) of Belarus and Revenue generated (in %) of Papua New Guinea?
Offer a very short reply. -20.51. In the year 1995, what is the difference between the Revenue generated (in %) in Belarus and Revenue generated (in %) in Yemen, Rep.?
Provide a short and direct response. -48.59. In the year 1995, what is the difference between the Revenue generated (in %) in Nepal and Revenue generated (in %) in Papua New Guinea?
Offer a terse response. 4.08. In the year 1995, what is the difference between the Revenue generated (in %) of Nepal and Revenue generated (in %) of Yemen, Rep.?
Give a very brief answer. -24. In the year 1995, what is the difference between the Revenue generated (in %) of Papua New Guinea and Revenue generated (in %) of Yemen, Rep.?
Your response must be concise. -28.09. In the year 1996, what is the difference between the Revenue generated (in %) of Belarus and Revenue generated (in %) of Nepal?
Your response must be concise. -23.53. In the year 1996, what is the difference between the Revenue generated (in %) of Belarus and Revenue generated (in %) of Papua New Guinea?
Offer a very short reply. -8.92. In the year 1996, what is the difference between the Revenue generated (in %) of Belarus and Revenue generated (in %) of Yemen, Rep.?
Keep it short and to the point. -55.62. In the year 1996, what is the difference between the Revenue generated (in %) of Nepal and Revenue generated (in %) of Papua New Guinea?
Provide a succinct answer. 14.62. In the year 1996, what is the difference between the Revenue generated (in %) in Nepal and Revenue generated (in %) in Yemen, Rep.?
Keep it short and to the point. -32.09. In the year 1996, what is the difference between the Revenue generated (in %) of Papua New Guinea and Revenue generated (in %) of Yemen, Rep.?
Your response must be concise. -46.71. In the year 1997, what is the difference between the Revenue generated (in %) of Belarus and Revenue generated (in %) of Nepal?
Give a very brief answer. -26.19. In the year 1997, what is the difference between the Revenue generated (in %) of Belarus and Revenue generated (in %) of Papua New Guinea?
Offer a very short reply. -15.1. In the year 1997, what is the difference between the Revenue generated (in %) of Belarus and Revenue generated (in %) of Yemen, Rep.?
Provide a short and direct response. -62.06. In the year 1997, what is the difference between the Revenue generated (in %) of Nepal and Revenue generated (in %) of Papua New Guinea?
Make the answer very short. 11.09. In the year 1997, what is the difference between the Revenue generated (in %) of Nepal and Revenue generated (in %) of Yemen, Rep.?
Give a very brief answer. -35.87. In the year 1997, what is the difference between the Revenue generated (in %) of Papua New Guinea and Revenue generated (in %) of Yemen, Rep.?
Offer a terse response. -46.96. In the year 1998, what is the difference between the Revenue generated (in %) of Belarus and Revenue generated (in %) of Nepal?
Your response must be concise. -22.37. In the year 1998, what is the difference between the Revenue generated (in %) in Belarus and Revenue generated (in %) in Papua New Guinea?
Your answer should be very brief. -13.25. In the year 1998, what is the difference between the Revenue generated (in %) of Belarus and Revenue generated (in %) of Yemen, Rep.?
Offer a very short reply. -56.42. In the year 1998, what is the difference between the Revenue generated (in %) in Nepal and Revenue generated (in %) in Papua New Guinea?
Offer a terse response. 9.12. In the year 1998, what is the difference between the Revenue generated (in %) of Nepal and Revenue generated (in %) of Yemen, Rep.?
Provide a succinct answer. -34.05. In the year 1998, what is the difference between the Revenue generated (in %) in Papua New Guinea and Revenue generated (in %) in Yemen, Rep.?
Give a very brief answer. -43.17. In the year 1999, what is the difference between the Revenue generated (in %) in Belarus and Revenue generated (in %) in Nepal?
Make the answer very short. -18.58. In the year 1999, what is the difference between the Revenue generated (in %) of Belarus and Revenue generated (in %) of Papua New Guinea?
Your response must be concise. -14.79. In the year 1999, what is the difference between the Revenue generated (in %) of Belarus and Revenue generated (in %) of Yemen, Rep.?
Your answer should be compact. -53.54. In the year 1999, what is the difference between the Revenue generated (in %) of Nepal and Revenue generated (in %) of Papua New Guinea?
Ensure brevity in your answer.  3.79. In the year 1999, what is the difference between the Revenue generated (in %) in Nepal and Revenue generated (in %) in Yemen, Rep.?
Make the answer very short. -34.96. In the year 1999, what is the difference between the Revenue generated (in %) in Papua New Guinea and Revenue generated (in %) in Yemen, Rep.?
Give a very brief answer. -38.75. What is the ratio of the Revenue generated (in %) of Belarus in 1992 to that in 1993?
Keep it short and to the point. 0.94. What is the ratio of the Revenue generated (in %) of Nepal in 1992 to that in 1993?
Your answer should be compact. 0.91. What is the ratio of the Revenue generated (in %) of Papua New Guinea in 1992 to that in 1993?
Your answer should be compact. 1.18. What is the ratio of the Revenue generated (in %) in Yemen, Rep. in 1992 to that in 1993?
Offer a terse response. 1.04. What is the ratio of the Revenue generated (in %) of Belarus in 1992 to that in 1994?
Provide a short and direct response. 1.96. What is the ratio of the Revenue generated (in %) of Nepal in 1992 to that in 1994?
Provide a short and direct response. 1.18. What is the ratio of the Revenue generated (in %) of Papua New Guinea in 1992 to that in 1994?
Your answer should be compact. 1.6. What is the ratio of the Revenue generated (in %) in Yemen, Rep. in 1992 to that in 1994?
Offer a very short reply. 1.08. What is the ratio of the Revenue generated (in %) of Belarus in 1992 to that in 1995?
Offer a very short reply. 1.18. What is the ratio of the Revenue generated (in %) in Nepal in 1992 to that in 1995?
Give a very brief answer. 1.19. What is the ratio of the Revenue generated (in %) in Papua New Guinea in 1992 to that in 1995?
Offer a very short reply. 1.31. What is the ratio of the Revenue generated (in %) of Yemen, Rep. in 1992 to that in 1995?
Provide a short and direct response. 0.83. What is the ratio of the Revenue generated (in %) in Belarus in 1992 to that in 1996?
Keep it short and to the point. 0.41. What is the ratio of the Revenue generated (in %) of Nepal in 1992 to that in 1996?
Give a very brief answer. 1.05. What is the ratio of the Revenue generated (in %) in Papua New Guinea in 1992 to that in 1996?
Your answer should be very brief. 1.86. What is the ratio of the Revenue generated (in %) of Yemen, Rep. in 1992 to that in 1996?
Ensure brevity in your answer.  0.68. What is the ratio of the Revenue generated (in %) of Belarus in 1992 to that in 1997?
Offer a terse response. 0.69. What is the ratio of the Revenue generated (in %) in Nepal in 1992 to that in 1997?
Offer a very short reply. 1.06. What is the ratio of the Revenue generated (in %) of Papua New Guinea in 1992 to that in 1997?
Keep it short and to the point. 1.55. What is the ratio of the Revenue generated (in %) in Yemen, Rep. in 1992 to that in 1997?
Give a very brief answer. 0.64. What is the ratio of the Revenue generated (in %) of Belarus in 1992 to that in 1998?
Provide a short and direct response. 0.44. What is the ratio of the Revenue generated (in %) of Nepal in 1992 to that in 1998?
Ensure brevity in your answer.  1.1. What is the ratio of the Revenue generated (in %) of Papua New Guinea in 1992 to that in 1998?
Give a very brief answer. 1.5. What is the ratio of the Revenue generated (in %) in Yemen, Rep. in 1992 to that in 1998?
Give a very brief answer. 0.67. What is the ratio of the Revenue generated (in %) of Belarus in 1992 to that in 1999?
Provide a succinct answer. 0.4. What is the ratio of the Revenue generated (in %) of Nepal in 1992 to that in 1999?
Provide a succinct answer. 1.23. What is the ratio of the Revenue generated (in %) of Papua New Guinea in 1992 to that in 1999?
Ensure brevity in your answer.  1.35. What is the ratio of the Revenue generated (in %) in Yemen, Rep. in 1992 to that in 1999?
Your response must be concise. 0.7. What is the ratio of the Revenue generated (in %) in Belarus in 1993 to that in 1994?
Keep it short and to the point. 2.08. What is the ratio of the Revenue generated (in %) of Nepal in 1993 to that in 1994?
Your answer should be compact. 1.29. What is the ratio of the Revenue generated (in %) in Papua New Guinea in 1993 to that in 1994?
Your answer should be very brief. 1.36. What is the ratio of the Revenue generated (in %) in Yemen, Rep. in 1993 to that in 1994?
Offer a terse response. 1.04. What is the ratio of the Revenue generated (in %) in Belarus in 1993 to that in 1995?
Make the answer very short. 1.25. What is the ratio of the Revenue generated (in %) of Nepal in 1993 to that in 1995?
Your response must be concise. 1.3. What is the ratio of the Revenue generated (in %) in Papua New Guinea in 1993 to that in 1995?
Your answer should be very brief. 1.11. What is the ratio of the Revenue generated (in %) in Yemen, Rep. in 1993 to that in 1995?
Ensure brevity in your answer.  0.81. What is the ratio of the Revenue generated (in %) in Belarus in 1993 to that in 1996?
Offer a terse response. 0.44. What is the ratio of the Revenue generated (in %) in Nepal in 1993 to that in 1996?
Provide a succinct answer. 1.14. What is the ratio of the Revenue generated (in %) in Papua New Guinea in 1993 to that in 1996?
Keep it short and to the point. 1.58. What is the ratio of the Revenue generated (in %) in Yemen, Rep. in 1993 to that in 1996?
Ensure brevity in your answer.  0.65. What is the ratio of the Revenue generated (in %) of Belarus in 1993 to that in 1997?
Your answer should be compact. 0.73. What is the ratio of the Revenue generated (in %) in Nepal in 1993 to that in 1997?
Keep it short and to the point. 1.16. What is the ratio of the Revenue generated (in %) of Papua New Guinea in 1993 to that in 1997?
Provide a succinct answer. 1.31. What is the ratio of the Revenue generated (in %) of Yemen, Rep. in 1993 to that in 1997?
Keep it short and to the point. 0.62. What is the ratio of the Revenue generated (in %) in Belarus in 1993 to that in 1998?
Offer a terse response. 0.46. What is the ratio of the Revenue generated (in %) of Nepal in 1993 to that in 1998?
Make the answer very short. 1.21. What is the ratio of the Revenue generated (in %) of Papua New Guinea in 1993 to that in 1998?
Your response must be concise. 1.27. What is the ratio of the Revenue generated (in %) in Yemen, Rep. in 1993 to that in 1998?
Make the answer very short. 0.65. What is the ratio of the Revenue generated (in %) of Belarus in 1993 to that in 1999?
Your answer should be very brief. 0.42. What is the ratio of the Revenue generated (in %) of Nepal in 1993 to that in 1999?
Offer a very short reply. 1.35. What is the ratio of the Revenue generated (in %) of Papua New Guinea in 1993 to that in 1999?
Your answer should be very brief. 1.15. What is the ratio of the Revenue generated (in %) in Yemen, Rep. in 1993 to that in 1999?
Offer a terse response. 0.67. What is the ratio of the Revenue generated (in %) of Belarus in 1994 to that in 1995?
Ensure brevity in your answer.  0.6. What is the ratio of the Revenue generated (in %) of Nepal in 1994 to that in 1995?
Offer a terse response. 1.01. What is the ratio of the Revenue generated (in %) of Papua New Guinea in 1994 to that in 1995?
Provide a succinct answer. 0.82. What is the ratio of the Revenue generated (in %) in Yemen, Rep. in 1994 to that in 1995?
Provide a succinct answer. 0.77. What is the ratio of the Revenue generated (in %) of Belarus in 1994 to that in 1996?
Make the answer very short. 0.21. What is the ratio of the Revenue generated (in %) in Nepal in 1994 to that in 1996?
Your answer should be compact. 0.89. What is the ratio of the Revenue generated (in %) of Papua New Guinea in 1994 to that in 1996?
Offer a terse response. 1.16. What is the ratio of the Revenue generated (in %) of Yemen, Rep. in 1994 to that in 1996?
Your answer should be compact. 0.63. What is the ratio of the Revenue generated (in %) of Belarus in 1994 to that in 1997?
Your answer should be compact. 0.35. What is the ratio of the Revenue generated (in %) of Nepal in 1994 to that in 1997?
Provide a succinct answer. 0.9. What is the ratio of the Revenue generated (in %) in Papua New Guinea in 1994 to that in 1997?
Offer a terse response. 0.97. What is the ratio of the Revenue generated (in %) of Yemen, Rep. in 1994 to that in 1997?
Provide a short and direct response. 0.6. What is the ratio of the Revenue generated (in %) of Belarus in 1994 to that in 1998?
Provide a short and direct response. 0.22. What is the ratio of the Revenue generated (in %) of Nepal in 1994 to that in 1998?
Your response must be concise. 0.94. What is the ratio of the Revenue generated (in %) of Papua New Guinea in 1994 to that in 1998?
Provide a succinct answer. 0.94. What is the ratio of the Revenue generated (in %) of Yemen, Rep. in 1994 to that in 1998?
Give a very brief answer. 0.62. What is the ratio of the Revenue generated (in %) of Belarus in 1994 to that in 1999?
Give a very brief answer. 0.2. What is the ratio of the Revenue generated (in %) of Nepal in 1994 to that in 1999?
Your response must be concise. 1.05. What is the ratio of the Revenue generated (in %) in Papua New Guinea in 1994 to that in 1999?
Ensure brevity in your answer.  0.84. What is the ratio of the Revenue generated (in %) of Yemen, Rep. in 1994 to that in 1999?
Ensure brevity in your answer.  0.65. What is the ratio of the Revenue generated (in %) of Belarus in 1995 to that in 1996?
Offer a terse response. 0.35. What is the ratio of the Revenue generated (in %) of Nepal in 1995 to that in 1996?
Keep it short and to the point. 0.88. What is the ratio of the Revenue generated (in %) in Papua New Guinea in 1995 to that in 1996?
Make the answer very short. 1.42. What is the ratio of the Revenue generated (in %) in Yemen, Rep. in 1995 to that in 1996?
Offer a terse response. 0.81. What is the ratio of the Revenue generated (in %) in Belarus in 1995 to that in 1997?
Give a very brief answer. 0.58. What is the ratio of the Revenue generated (in %) of Nepal in 1995 to that in 1997?
Make the answer very short. 0.89. What is the ratio of the Revenue generated (in %) of Papua New Guinea in 1995 to that in 1997?
Provide a short and direct response. 1.18. What is the ratio of the Revenue generated (in %) in Yemen, Rep. in 1995 to that in 1997?
Provide a short and direct response. 0.77. What is the ratio of the Revenue generated (in %) in Belarus in 1995 to that in 1998?
Keep it short and to the point. 0.37. What is the ratio of the Revenue generated (in %) in Nepal in 1995 to that in 1998?
Provide a succinct answer. 0.93. What is the ratio of the Revenue generated (in %) in Papua New Guinea in 1995 to that in 1998?
Ensure brevity in your answer.  1.14. What is the ratio of the Revenue generated (in %) of Yemen, Rep. in 1995 to that in 1998?
Provide a short and direct response. 0.81. What is the ratio of the Revenue generated (in %) in Belarus in 1995 to that in 1999?
Offer a very short reply. 0.34. What is the ratio of the Revenue generated (in %) in Nepal in 1995 to that in 1999?
Your answer should be very brief. 1.04. What is the ratio of the Revenue generated (in %) of Papua New Guinea in 1995 to that in 1999?
Keep it short and to the point. 1.03. What is the ratio of the Revenue generated (in %) of Yemen, Rep. in 1995 to that in 1999?
Your response must be concise. 0.84. What is the ratio of the Revenue generated (in %) in Belarus in 1996 to that in 1997?
Make the answer very short. 1.66. What is the ratio of the Revenue generated (in %) of Nepal in 1996 to that in 1997?
Your response must be concise. 1.01. What is the ratio of the Revenue generated (in %) in Papua New Guinea in 1996 to that in 1997?
Keep it short and to the point. 0.83. What is the ratio of the Revenue generated (in %) in Yemen, Rep. in 1996 to that in 1997?
Ensure brevity in your answer.  0.95. What is the ratio of the Revenue generated (in %) in Belarus in 1996 to that in 1998?
Your answer should be compact. 1.06. What is the ratio of the Revenue generated (in %) in Nepal in 1996 to that in 1998?
Your answer should be very brief. 1.05. What is the ratio of the Revenue generated (in %) of Papua New Guinea in 1996 to that in 1998?
Offer a terse response. 0.81. What is the ratio of the Revenue generated (in %) in Belarus in 1996 to that in 1999?
Provide a short and direct response. 0.97. What is the ratio of the Revenue generated (in %) in Nepal in 1996 to that in 1999?
Your response must be concise. 1.18. What is the ratio of the Revenue generated (in %) of Papua New Guinea in 1996 to that in 1999?
Ensure brevity in your answer.  0.73. What is the ratio of the Revenue generated (in %) of Yemen, Rep. in 1996 to that in 1999?
Provide a short and direct response. 1.03. What is the ratio of the Revenue generated (in %) of Belarus in 1997 to that in 1998?
Keep it short and to the point. 0.64. What is the ratio of the Revenue generated (in %) in Nepal in 1997 to that in 1998?
Give a very brief answer. 1.04. What is the ratio of the Revenue generated (in %) of Papua New Guinea in 1997 to that in 1998?
Make the answer very short. 0.97. What is the ratio of the Revenue generated (in %) of Yemen, Rep. in 1997 to that in 1998?
Your answer should be very brief. 1.05. What is the ratio of the Revenue generated (in %) in Belarus in 1997 to that in 1999?
Give a very brief answer. 0.58. What is the ratio of the Revenue generated (in %) of Nepal in 1997 to that in 1999?
Provide a succinct answer. 1.17. What is the ratio of the Revenue generated (in %) in Papua New Guinea in 1997 to that in 1999?
Your answer should be very brief. 0.87. What is the ratio of the Revenue generated (in %) of Yemen, Rep. in 1997 to that in 1999?
Your response must be concise. 1.09. What is the ratio of the Revenue generated (in %) of Belarus in 1998 to that in 1999?
Provide a succinct answer. 0.91. What is the ratio of the Revenue generated (in %) in Nepal in 1998 to that in 1999?
Keep it short and to the point. 1.12. What is the ratio of the Revenue generated (in %) in Papua New Guinea in 1998 to that in 1999?
Provide a short and direct response. 0.9. What is the ratio of the Revenue generated (in %) of Yemen, Rep. in 1998 to that in 1999?
Offer a terse response. 1.04. What is the difference between the highest and the second highest Revenue generated (in %) of Belarus?
Your answer should be compact. 0.25. What is the difference between the highest and the second highest Revenue generated (in %) in Nepal?
Keep it short and to the point. 3.02. What is the difference between the highest and the second highest Revenue generated (in %) in Papua New Guinea?
Ensure brevity in your answer.  4.57. What is the difference between the highest and the second highest Revenue generated (in %) in Yemen, Rep.?
Provide a succinct answer. 3.14. What is the difference between the highest and the lowest Revenue generated (in %) in Belarus?
Make the answer very short. 6.09. What is the difference between the highest and the lowest Revenue generated (in %) of Nepal?
Give a very brief answer. 9.17. What is the difference between the highest and the lowest Revenue generated (in %) of Papua New Guinea?
Keep it short and to the point. 13.96. What is the difference between the highest and the lowest Revenue generated (in %) in Yemen, Rep.?
Keep it short and to the point. 26.9. 